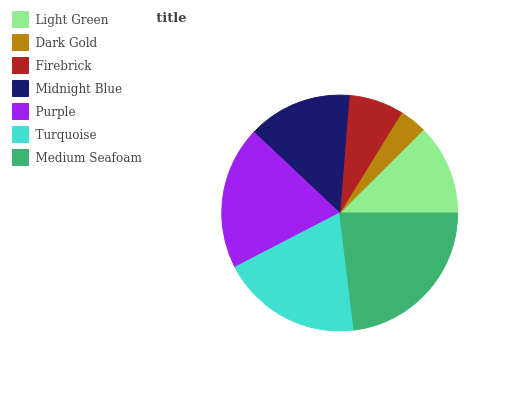Is Dark Gold the minimum?
Answer yes or no. Yes. Is Medium Seafoam the maximum?
Answer yes or no. Yes. Is Firebrick the minimum?
Answer yes or no. No. Is Firebrick the maximum?
Answer yes or no. No. Is Firebrick greater than Dark Gold?
Answer yes or no. Yes. Is Dark Gold less than Firebrick?
Answer yes or no. Yes. Is Dark Gold greater than Firebrick?
Answer yes or no. No. Is Firebrick less than Dark Gold?
Answer yes or no. No. Is Midnight Blue the high median?
Answer yes or no. Yes. Is Midnight Blue the low median?
Answer yes or no. Yes. Is Firebrick the high median?
Answer yes or no. No. Is Medium Seafoam the low median?
Answer yes or no. No. 